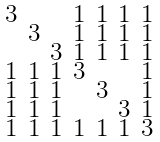<formula> <loc_0><loc_0><loc_500><loc_500>\begin{smallmatrix} 3 & & & 1 & 1 & 1 & 1 \\ & 3 & & 1 & 1 & 1 & 1 \\ & & 3 & 1 & 1 & 1 & 1 \\ 1 & 1 & 1 & 3 & & & 1 \\ 1 & 1 & 1 & & 3 & & 1 \\ 1 & 1 & 1 & & & 3 & 1 \\ 1 & 1 & 1 & 1 & 1 & 1 & 3 \end{smallmatrix}</formula> 